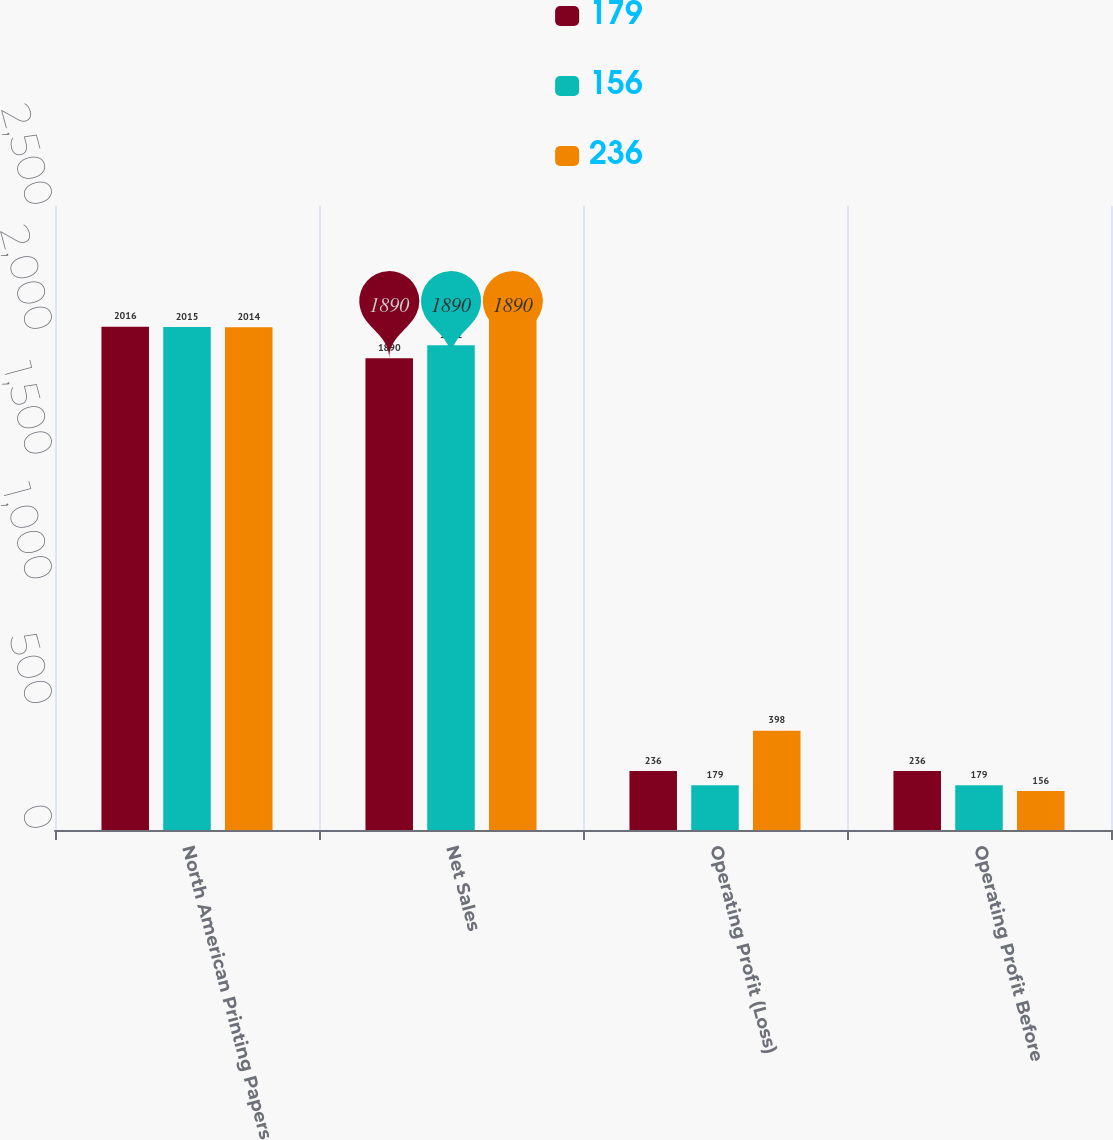Convert chart. <chart><loc_0><loc_0><loc_500><loc_500><stacked_bar_chart><ecel><fcel>North American Printing Papers<fcel>Net Sales<fcel>Operating Profit (Loss)<fcel>Operating Profit Before<nl><fcel>179<fcel>2016<fcel>1890<fcel>236<fcel>236<nl><fcel>156<fcel>2015<fcel>1942<fcel>179<fcel>179<nl><fcel>236<fcel>2014<fcel>2055<fcel>398<fcel>156<nl></chart> 